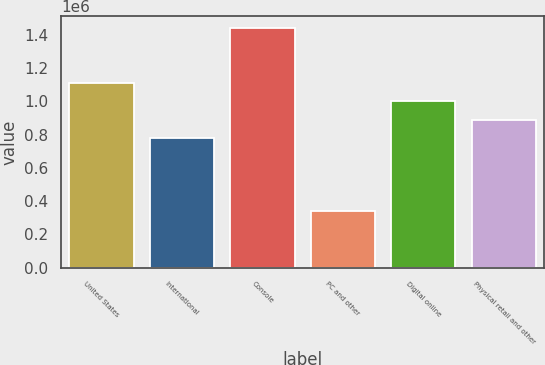Convert chart. <chart><loc_0><loc_0><loc_500><loc_500><bar_chart><fcel>United States<fcel>International<fcel>Console<fcel>PC and other<fcel>Digital online<fcel>Physical retail and other<nl><fcel>1.11113e+06<fcel>780620<fcel>1.44072e+06<fcel>339024<fcel>1.00096e+06<fcel>890790<nl></chart> 